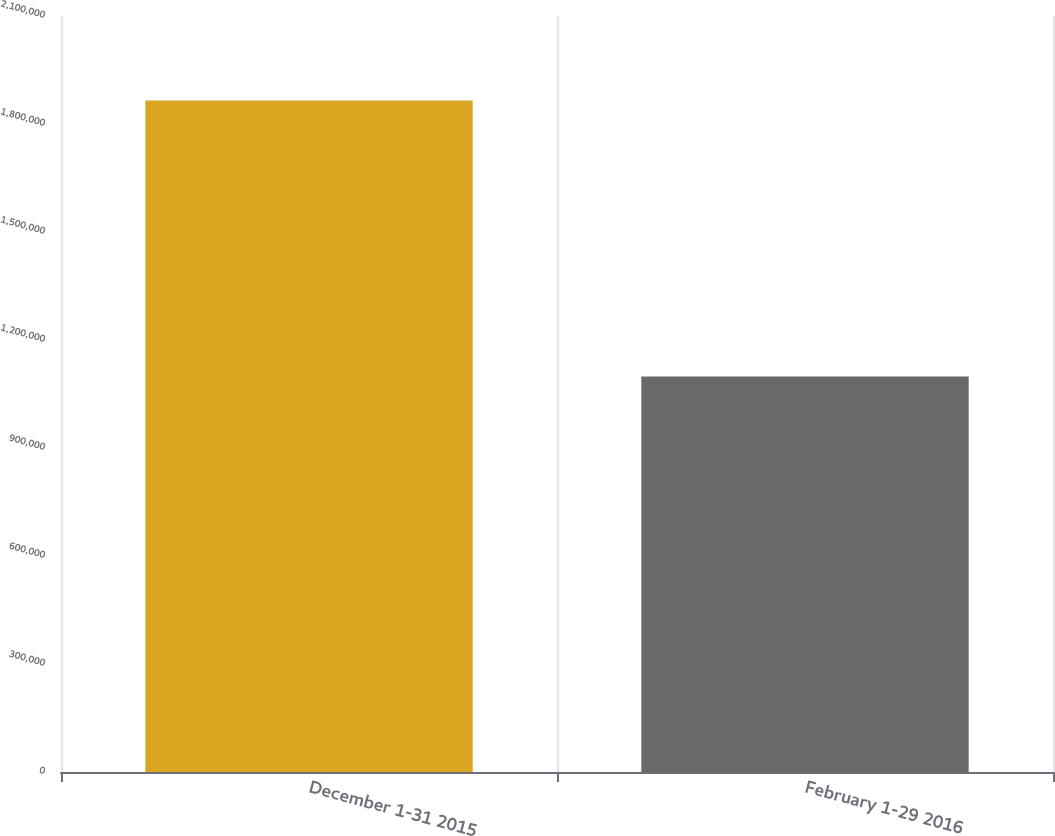Convert chart. <chart><loc_0><loc_0><loc_500><loc_500><bar_chart><fcel>December 1-31 2015<fcel>February 1-29 2016<nl><fcel>1.86508e+06<fcel>1.0989e+06<nl></chart> 